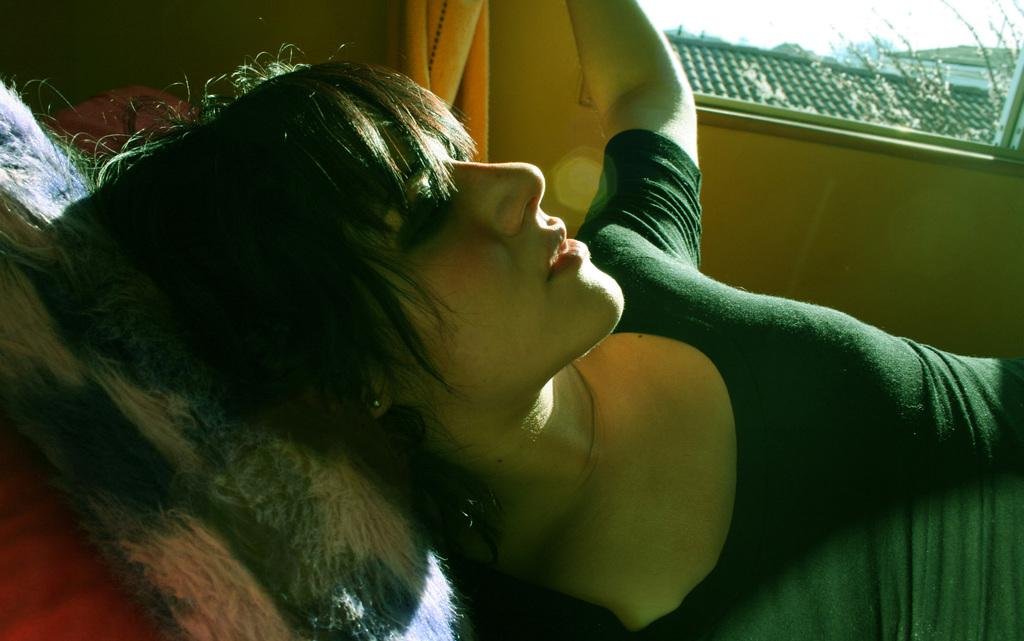What is the lady in the image doing? The lady is lying down in the image. What is supporting the lady's head? The lady's head is on a pillow. What can be seen in the background of the image? There is a wall and a window in the background of the image. What is visible through the window? The roof is visible through the window. What type of calculator is the lady using in the image? There is no calculator present in the image. Can you tell me where the drum is located in the image? There is no drum present in the image. 